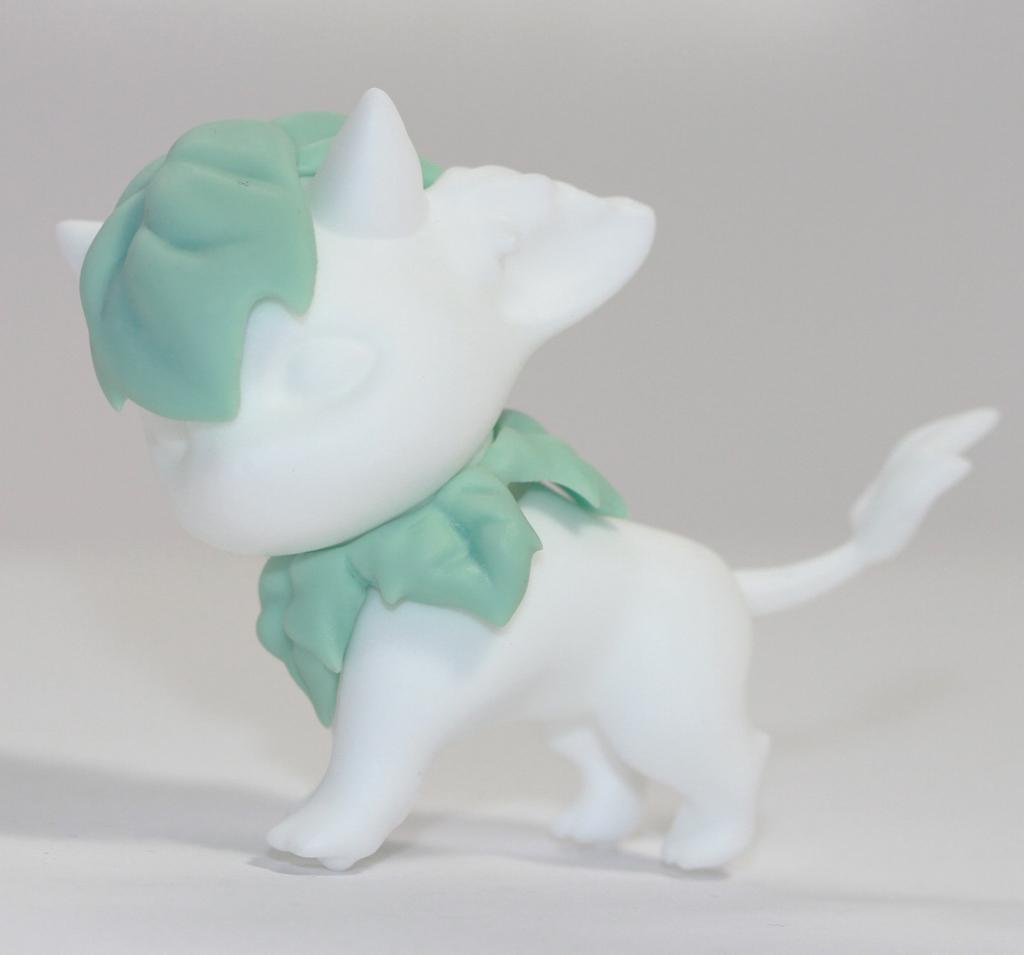Describe this image in one or two sentences. In this image we can see a toy on a surface. In the background it is white. 